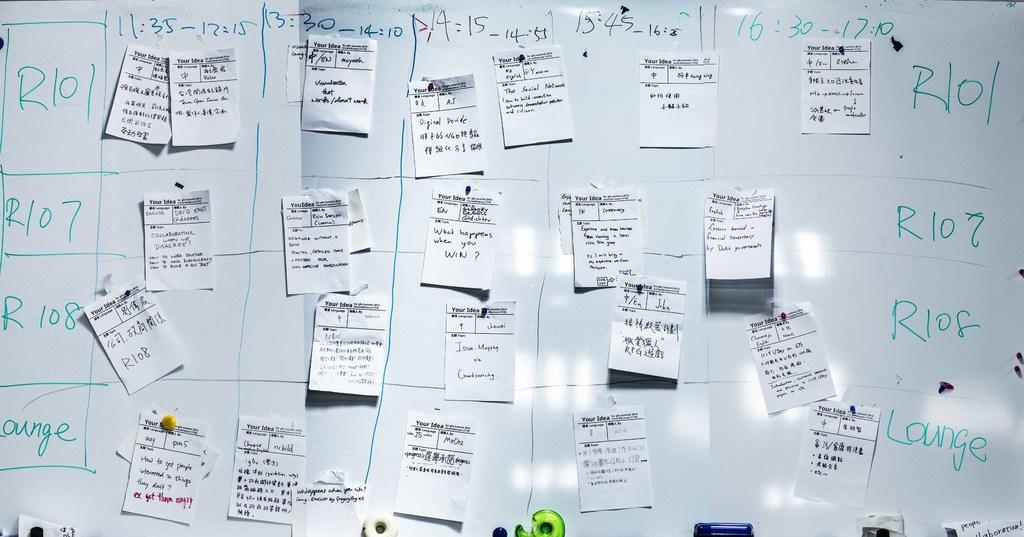<image>
Offer a succinct explanation of the picture presented. A whiteboard with "Lounge" written on it and covered in detailed sticky notes. 